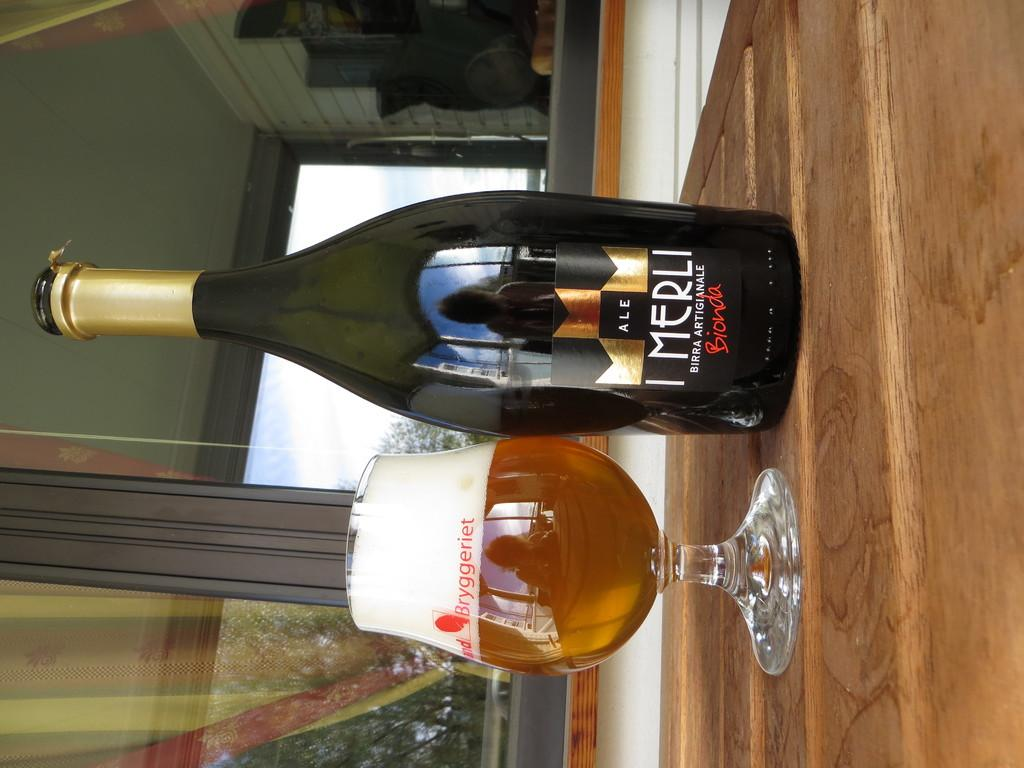<image>
Render a clear and concise summary of the photo. A black and gold bottle of Imerli next to a full, foaming cup. 